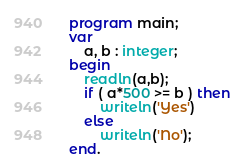<code> <loc_0><loc_0><loc_500><loc_500><_Pascal_>program main;
var 
    a, b : integer;
begin
    readln(a,b);
    if ( a*500 >= b ) then 
        writeln('Yes')
    else 
        writeln('No');
end.</code> 